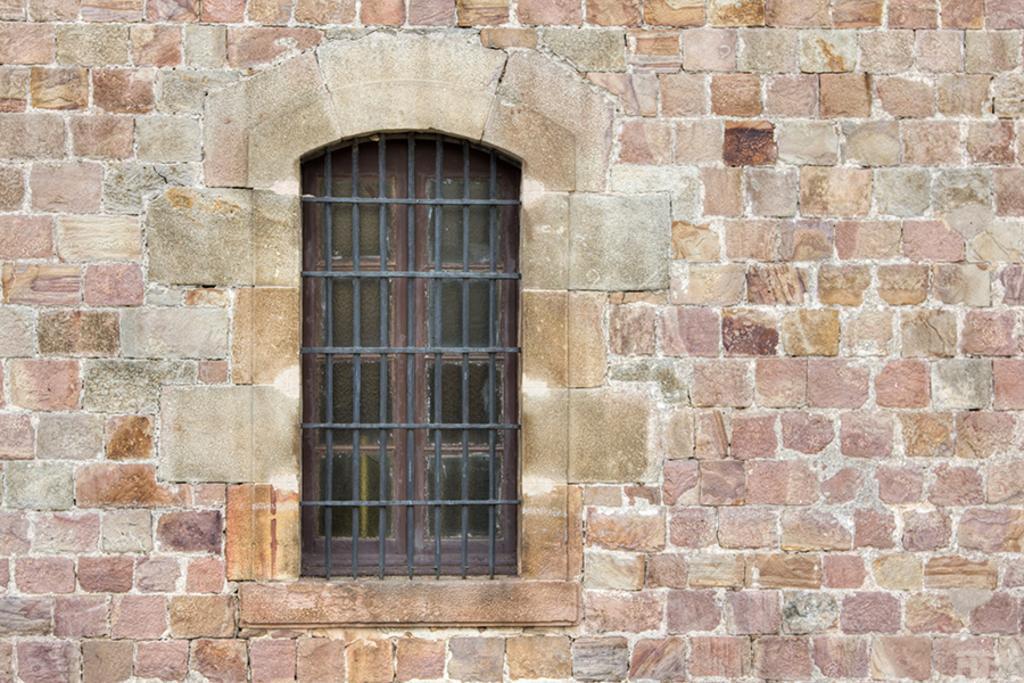Describe this image in one or two sentences. In this picture we can see a brick wall with a window and iron grills. 